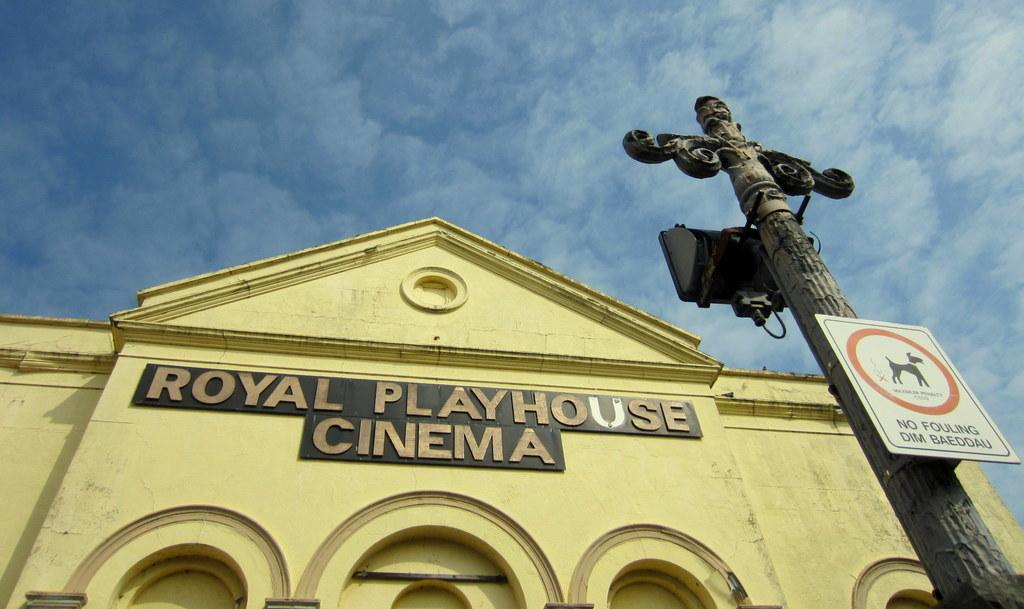<image>
Summarize the visual content of the image. An upwards look at the outside of the Royal Playhouse Cinema 